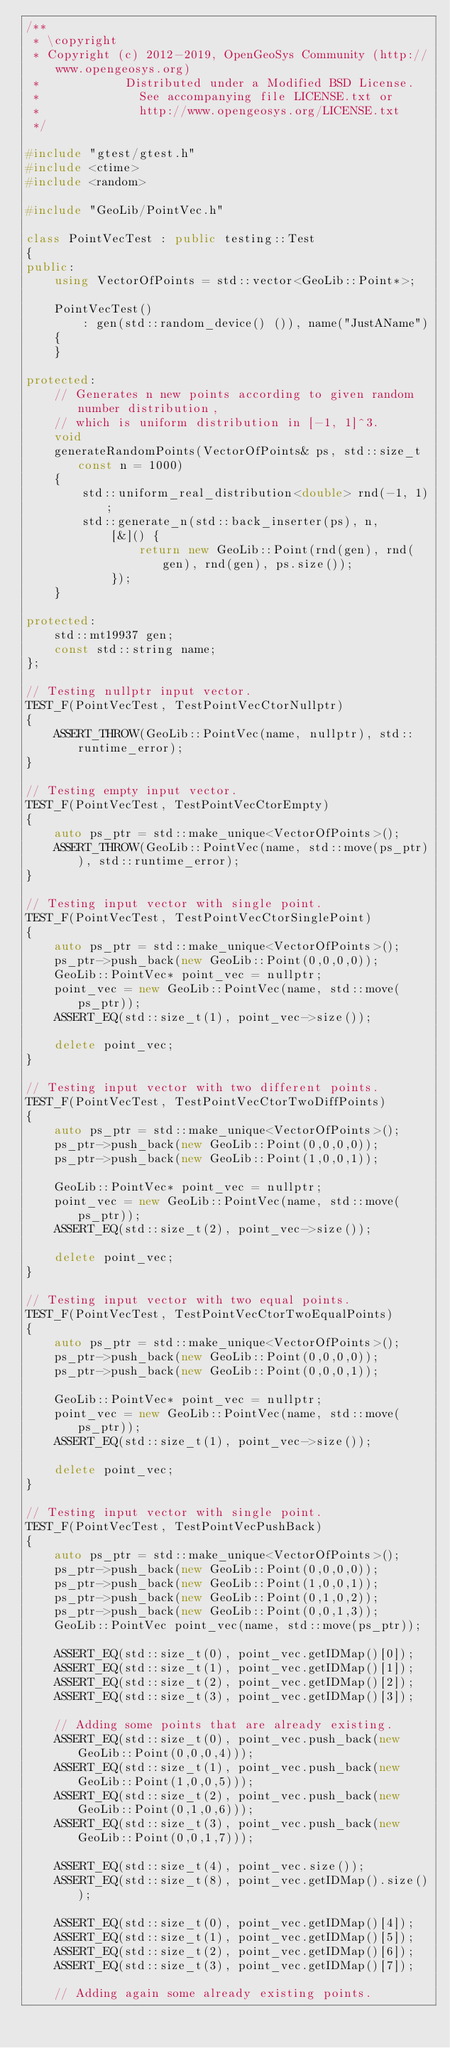<code> <loc_0><loc_0><loc_500><loc_500><_C++_>/**
 * \copyright
 * Copyright (c) 2012-2019, OpenGeoSys Community (http://www.opengeosys.org)
 *            Distributed under a Modified BSD License.
 *              See accompanying file LICENSE.txt or
 *              http://www.opengeosys.org/LICENSE.txt
 */

#include "gtest/gtest.h"
#include <ctime>
#include <random>

#include "GeoLib/PointVec.h"

class PointVecTest : public testing::Test
{
public:
    using VectorOfPoints = std::vector<GeoLib::Point*>;

    PointVecTest()
        : gen(std::random_device() ()), name("JustAName")
    {
    }

protected:
    // Generates n new points according to given random number distribution,
    // which is uniform distribution in [-1, 1]^3.
    void
    generateRandomPoints(VectorOfPoints& ps, std::size_t const n = 1000)
    {
        std::uniform_real_distribution<double> rnd(-1, 1);
        std::generate_n(std::back_inserter(ps), n,
            [&]() {
                return new GeoLib::Point(rnd(gen), rnd(gen), rnd(gen), ps.size());
            });
    }

protected:
    std::mt19937 gen;
    const std::string name;
};

// Testing nullptr input vector.
TEST_F(PointVecTest, TestPointVecCtorNullptr)
{
    ASSERT_THROW(GeoLib::PointVec(name, nullptr), std::runtime_error);
}

// Testing empty input vector.
TEST_F(PointVecTest, TestPointVecCtorEmpty)
{
    auto ps_ptr = std::make_unique<VectorOfPoints>();
    ASSERT_THROW(GeoLib::PointVec(name, std::move(ps_ptr)), std::runtime_error);
}

// Testing input vector with single point.
TEST_F(PointVecTest, TestPointVecCtorSinglePoint)
{
    auto ps_ptr = std::make_unique<VectorOfPoints>();
    ps_ptr->push_back(new GeoLib::Point(0,0,0,0));
    GeoLib::PointVec* point_vec = nullptr;
    point_vec = new GeoLib::PointVec(name, std::move(ps_ptr));
    ASSERT_EQ(std::size_t(1), point_vec->size());

    delete point_vec;
}

// Testing input vector with two different points.
TEST_F(PointVecTest, TestPointVecCtorTwoDiffPoints)
{
    auto ps_ptr = std::make_unique<VectorOfPoints>();
    ps_ptr->push_back(new GeoLib::Point(0,0,0,0));
    ps_ptr->push_back(new GeoLib::Point(1,0,0,1));

    GeoLib::PointVec* point_vec = nullptr;
    point_vec = new GeoLib::PointVec(name, std::move(ps_ptr));
    ASSERT_EQ(std::size_t(2), point_vec->size());

    delete point_vec;
}

// Testing input vector with two equal points.
TEST_F(PointVecTest, TestPointVecCtorTwoEqualPoints)
{
    auto ps_ptr = std::make_unique<VectorOfPoints>();
    ps_ptr->push_back(new GeoLib::Point(0,0,0,0));
    ps_ptr->push_back(new GeoLib::Point(0,0,0,1));

    GeoLib::PointVec* point_vec = nullptr;
    point_vec = new GeoLib::PointVec(name, std::move(ps_ptr));
    ASSERT_EQ(std::size_t(1), point_vec->size());

    delete point_vec;
}

// Testing input vector with single point.
TEST_F(PointVecTest, TestPointVecPushBack)
{
    auto ps_ptr = std::make_unique<VectorOfPoints>();
    ps_ptr->push_back(new GeoLib::Point(0,0,0,0));
    ps_ptr->push_back(new GeoLib::Point(1,0,0,1));
    ps_ptr->push_back(new GeoLib::Point(0,1,0,2));
    ps_ptr->push_back(new GeoLib::Point(0,0,1,3));
    GeoLib::PointVec point_vec(name, std::move(ps_ptr));

    ASSERT_EQ(std::size_t(0), point_vec.getIDMap()[0]);
    ASSERT_EQ(std::size_t(1), point_vec.getIDMap()[1]);
    ASSERT_EQ(std::size_t(2), point_vec.getIDMap()[2]);
    ASSERT_EQ(std::size_t(3), point_vec.getIDMap()[3]);

    // Adding some points that are already existing.
    ASSERT_EQ(std::size_t(0), point_vec.push_back(new GeoLib::Point(0,0,0,4)));
    ASSERT_EQ(std::size_t(1), point_vec.push_back(new GeoLib::Point(1,0,0,5)));
    ASSERT_EQ(std::size_t(2), point_vec.push_back(new GeoLib::Point(0,1,0,6)));
    ASSERT_EQ(std::size_t(3), point_vec.push_back(new GeoLib::Point(0,0,1,7)));

    ASSERT_EQ(std::size_t(4), point_vec.size());
    ASSERT_EQ(std::size_t(8), point_vec.getIDMap().size());

    ASSERT_EQ(std::size_t(0), point_vec.getIDMap()[4]);
    ASSERT_EQ(std::size_t(1), point_vec.getIDMap()[5]);
    ASSERT_EQ(std::size_t(2), point_vec.getIDMap()[6]);
    ASSERT_EQ(std::size_t(3), point_vec.getIDMap()[7]);

    // Adding again some already existing points.</code> 